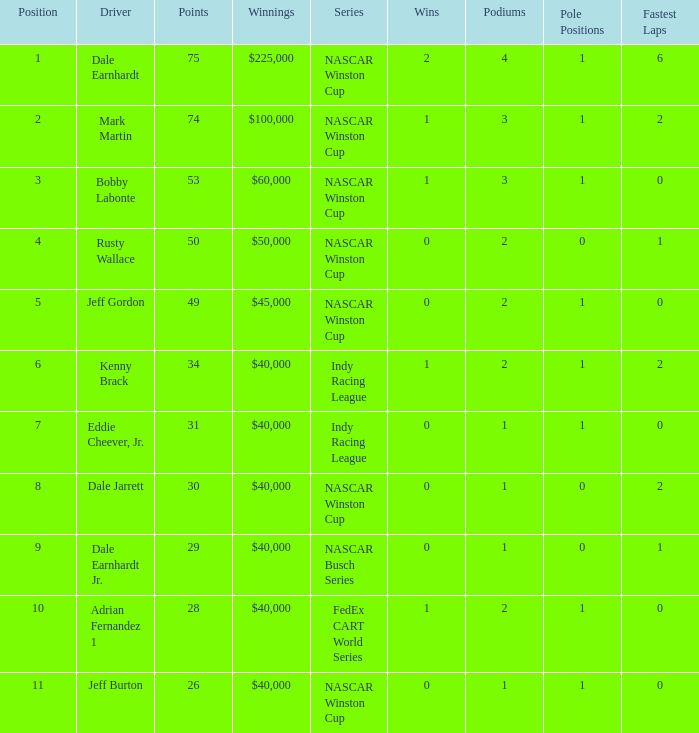In what position was the driver who won $60,000? 3.0. 